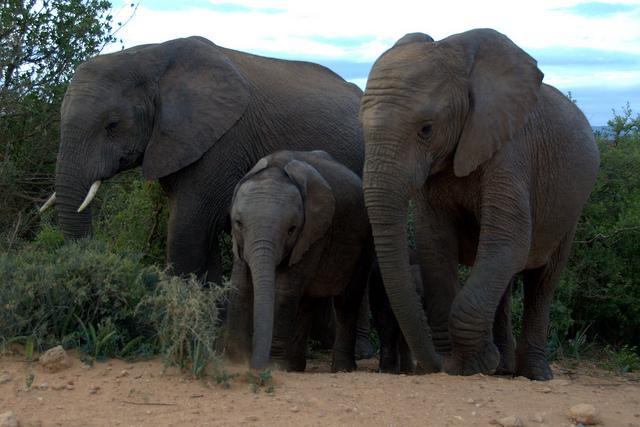What is the baby elephant called? Please explain your reasoning. calf. The name is used for young herd mammals. 